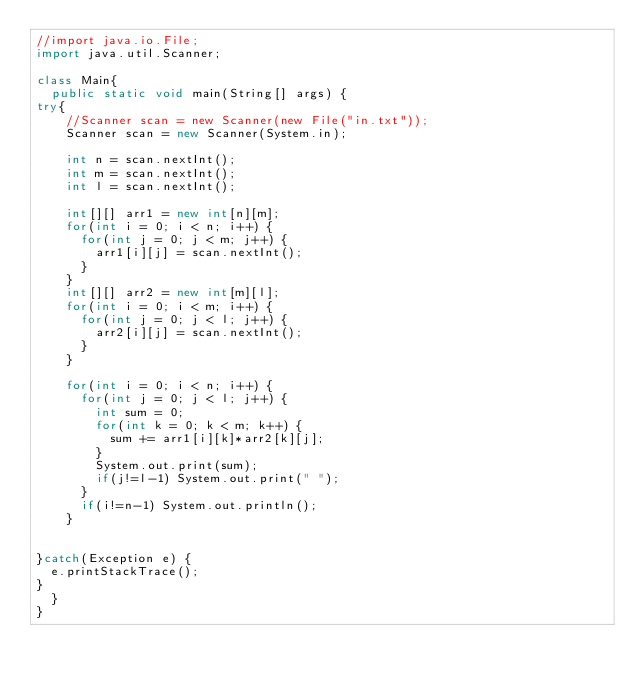<code> <loc_0><loc_0><loc_500><loc_500><_Java_>//import java.io.File;
import java.util.Scanner;

class Main{
	public static void main(String[] args) {
try{
		//Scanner scan = new Scanner(new File("in.txt"));
		Scanner scan = new Scanner(System.in);

		int n = scan.nextInt();
		int m = scan.nextInt();
		int l = scan.nextInt();

		int[][] arr1 = new int[n][m];
		for(int i = 0; i < n; i++) {
			for(int j = 0; j < m; j++) {
				arr1[i][j] = scan.nextInt();
			}
		}
		int[][] arr2 = new int[m][l];
		for(int i = 0; i < m; i++) {
			for(int j = 0; j < l; j++) {
				arr2[i][j] = scan.nextInt();
			}
		}

		for(int i = 0; i < n; i++) {
			for(int j = 0; j < l; j++) {
				int sum = 0;
				for(int k = 0; k < m; k++) {
					sum += arr1[i][k]*arr2[k][j];
				}
				System.out.print(sum);
				if(j!=l-1) System.out.print(" ");
			}
			if(i!=n-1) System.out.println();
		}
		

}catch(Exception e) {
	e.printStackTrace();
}
	}
}</code> 